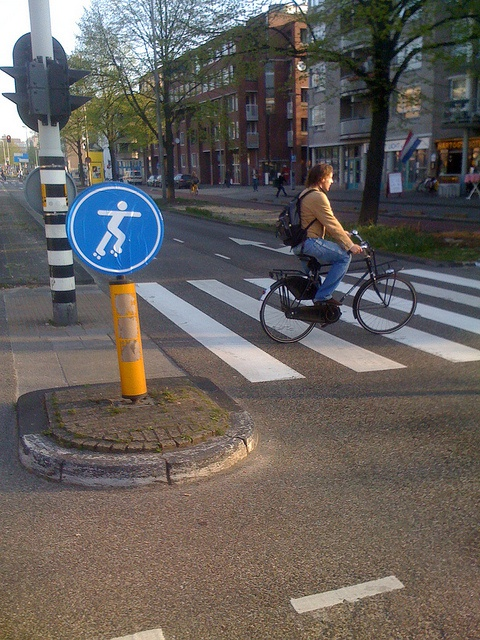Describe the objects in this image and their specific colors. I can see bicycle in white, black, gray, and darkgray tones, people in white, navy, black, brown, and gray tones, traffic light in white, gray, and blue tones, traffic light in white, black, darkblue, and gray tones, and backpack in white, black, and gray tones in this image. 